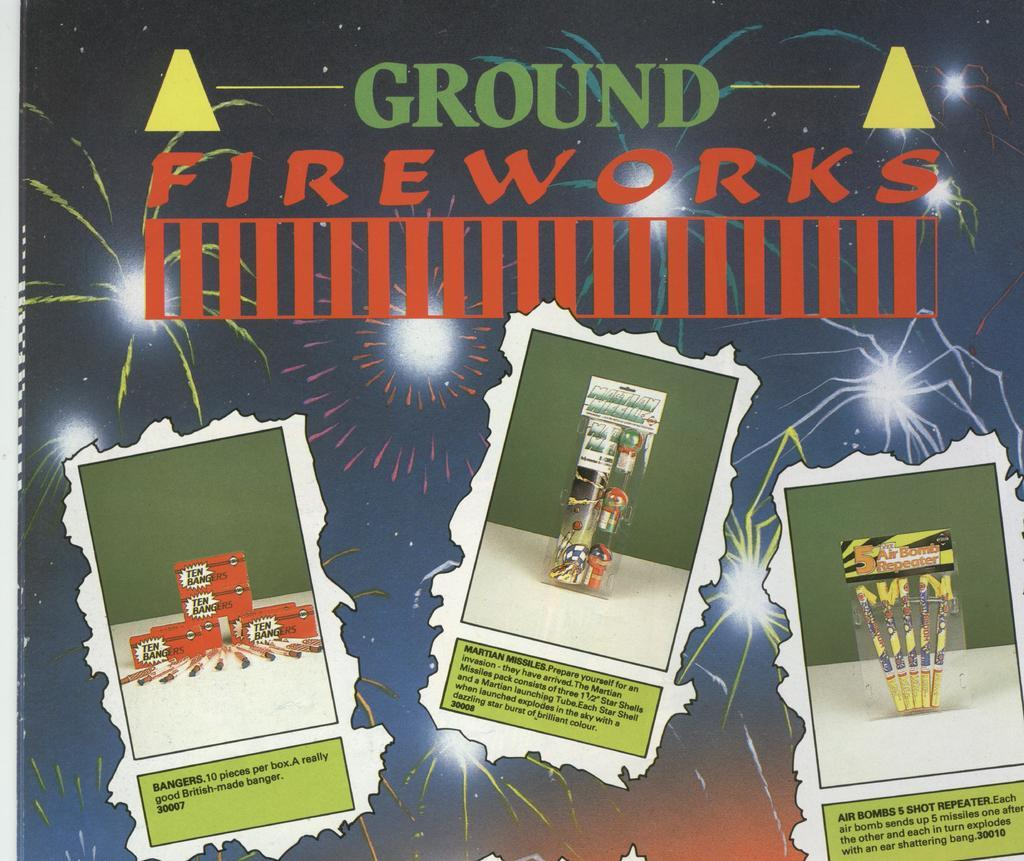Provide a one-sentence caption for the provided image. An advertisement for ground fireworks that shows three different sets. 